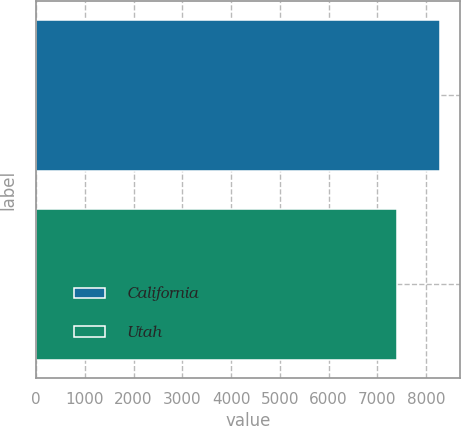<chart> <loc_0><loc_0><loc_500><loc_500><bar_chart><fcel>California<fcel>Utah<nl><fcel>8284<fcel>7411<nl></chart> 